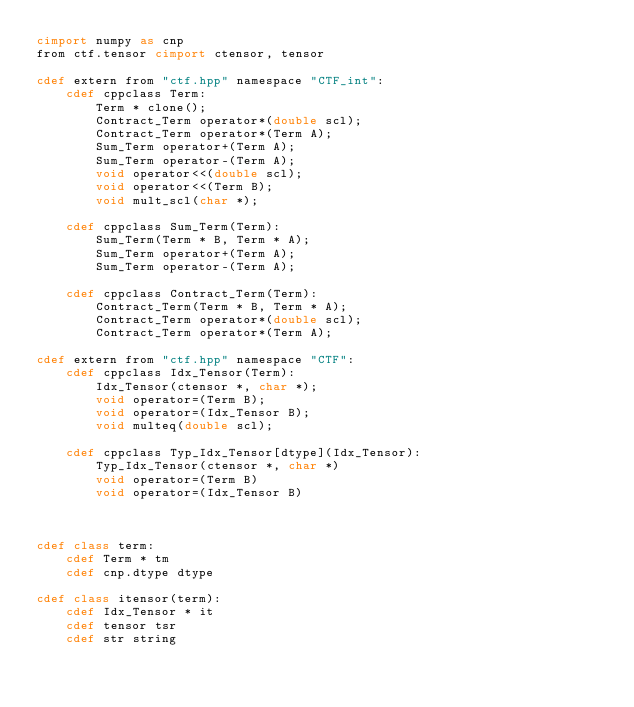Convert code to text. <code><loc_0><loc_0><loc_500><loc_500><_Cython_>cimport numpy as cnp
from ctf.tensor cimport ctensor, tensor

cdef extern from "ctf.hpp" namespace "CTF_int":
    cdef cppclass Term:
        Term * clone();
        Contract_Term operator*(double scl);
        Contract_Term operator*(Term A);
        Sum_Term operator+(Term A);
        Sum_Term operator-(Term A);
        void operator<<(double scl);
        void operator<<(Term B);
        void mult_scl(char *);
    
    cdef cppclass Sum_Term(Term):
        Sum_Term(Term * B, Term * A);
        Sum_Term operator+(Term A);
        Sum_Term operator-(Term A);

    cdef cppclass Contract_Term(Term):
        Contract_Term(Term * B, Term * A);
        Contract_Term operator*(double scl);
        Contract_Term operator*(Term A);

cdef extern from "ctf.hpp" namespace "CTF":
    cdef cppclass Idx_Tensor(Term):
        Idx_Tensor(ctensor *, char *);
        void operator=(Term B);
        void operator=(Idx_Tensor B);
        void multeq(double scl);

    cdef cppclass Typ_Idx_Tensor[dtype](Idx_Tensor):
        Typ_Idx_Tensor(ctensor *, char *)
        void operator=(Term B)
        void operator=(Idx_Tensor B)



cdef class term:
    cdef Term * tm
    cdef cnp.dtype dtype

cdef class itensor(term):
    cdef Idx_Tensor * it
    cdef tensor tsr
    cdef str string


</code> 